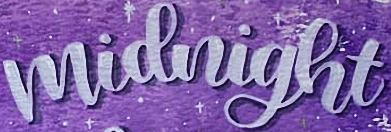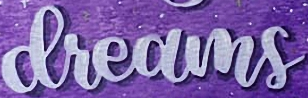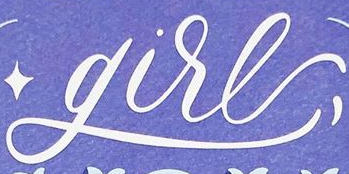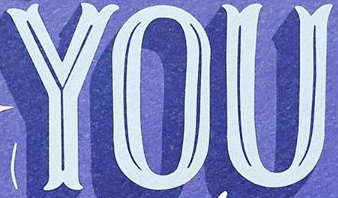What text is displayed in these images sequentially, separated by a semicolon? midnight; dreams; gire; YOU 